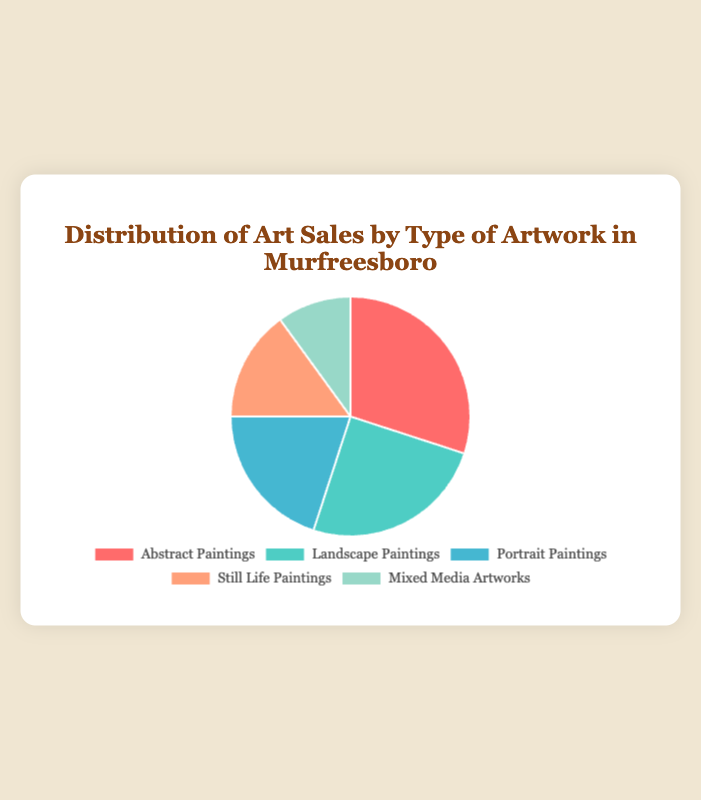What's the most popular type of artwork based on sales? The type with the highest percentage in the pie chart is the most popular. Abstract Paintings have the largest slice.
Answer: Abstract Paintings Which type of artwork sells the least in Murfreesboro? The type with the smallest percentage in the pie chart is the least popular. Mixed Media Artworks have the smallest slice.
Answer: Mixed Media Artworks How many more percentage points do Abstract Paintings have over Still Life Paintings? Abstract Paintings are 30% and Still Life Paintings are 15%. The difference is 30 - 15 = 15 percentage points.
Answer: 15 What is the combined percentage of sales for Portrait and Still Life Paintings? Portrait Paintings are 20%, and Still Life Paintings are 15%. Their combined percentage is 20 + 15 = 35%.
Answer: 35% Which type of artwork has a percentage exactly in between Landscape Paintings and Mixed Media Artworks? Landscape Paintings are 25%, and Mixed Media Artworks are 10%. The middle type, based on the given data, is Portrait Paintings at 20%.
Answer: Portrait Paintings Are there more sales of Landscape Paintings or Mixed Media Artworks? The pie chart shows that Landscape Paintings have 25%, and Mixed Media Artworks have 10%. 25% > 10%, so Landscape Paintings have more sales.
Answer: Landscape Paintings What color segment represents Portrait Paintings in the pie chart? The color segment for Portrait Paintings would be the third color in the order, which is blue.
Answer: Blue What is the median percentage of the given artwork sales distribution? The sorted percentages are 10%, 15%, 20%, 25%, 30%. The median value is the middle value, which is 20%.
Answer: 20% By how many percentage points do Landscape Paintings outsell Portrait Paintings? Landscape Paintings are 25%, and Portrait Paintings are 20%. The difference is 25 - 20 = 5 percentage points.
Answer: 5 What is the sum of the percentages for Abstract Paintings, Landscape Paintings, and Mixed Media Artworks? Abstract Paintings are 30%, Landscape Paintings are 25%, and Mixed Media Artworks are 10%. Their combined percentage is 30 + 25 + 10 = 65%.
Answer: 65% 